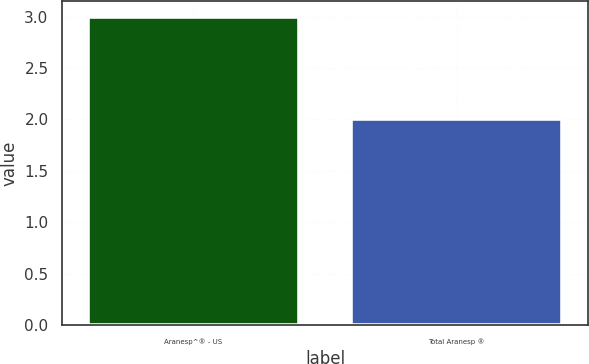Convert chart. <chart><loc_0><loc_0><loc_500><loc_500><bar_chart><fcel>Aranesp^® - US<fcel>Total Aranesp ®<nl><fcel>3<fcel>2<nl></chart> 